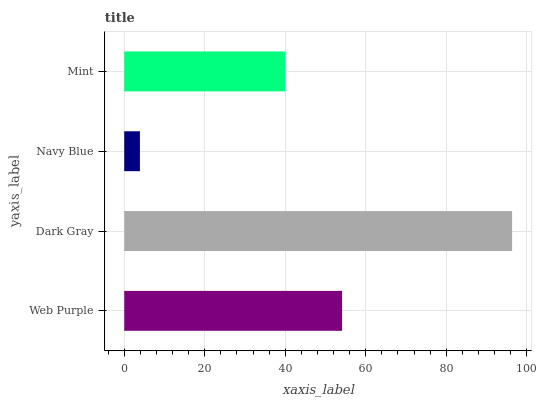Is Navy Blue the minimum?
Answer yes or no. Yes. Is Dark Gray the maximum?
Answer yes or no. Yes. Is Dark Gray the minimum?
Answer yes or no. No. Is Navy Blue the maximum?
Answer yes or no. No. Is Dark Gray greater than Navy Blue?
Answer yes or no. Yes. Is Navy Blue less than Dark Gray?
Answer yes or no. Yes. Is Navy Blue greater than Dark Gray?
Answer yes or no. No. Is Dark Gray less than Navy Blue?
Answer yes or no. No. Is Web Purple the high median?
Answer yes or no. Yes. Is Mint the low median?
Answer yes or no. Yes. Is Mint the high median?
Answer yes or no. No. Is Web Purple the low median?
Answer yes or no. No. 